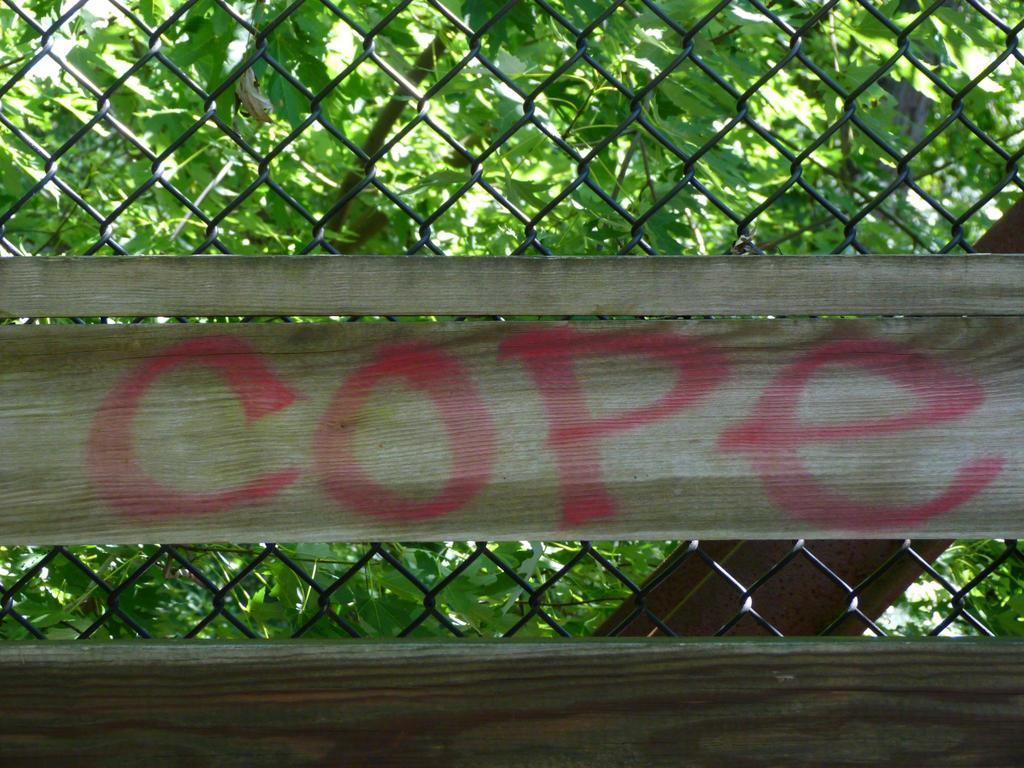What is placed on the fence in the image? There is a cloth on a fence in the image. What can be seen behind the fence in the image? There are many trees visible behind the fence in the image. What actor is performing in front of the shop in the image? There is no actor or shop present in the image; it features a cloth on a fence and trees in the background. 